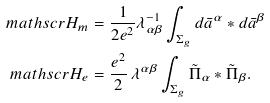Convert formula to latex. <formula><loc_0><loc_0><loc_500><loc_500>\ m a t h s c r { H } _ { m } & = \frac { 1 } { 2 e ^ { 2 } } \lambda ^ { - 1 } _ { \alpha \beta } \int _ { \Sigma _ { g } } d \bar { a } ^ { \alpha } * d \bar { a } ^ { \beta } \\ \ m a t h s c r { H } _ { e } & = \frac { e ^ { 2 } } { 2 } \, \lambda ^ { \alpha \beta } \int _ { \Sigma _ { g } } \tilde { \Pi } _ { \alpha } * \tilde { \Pi } _ { \beta } .</formula> 